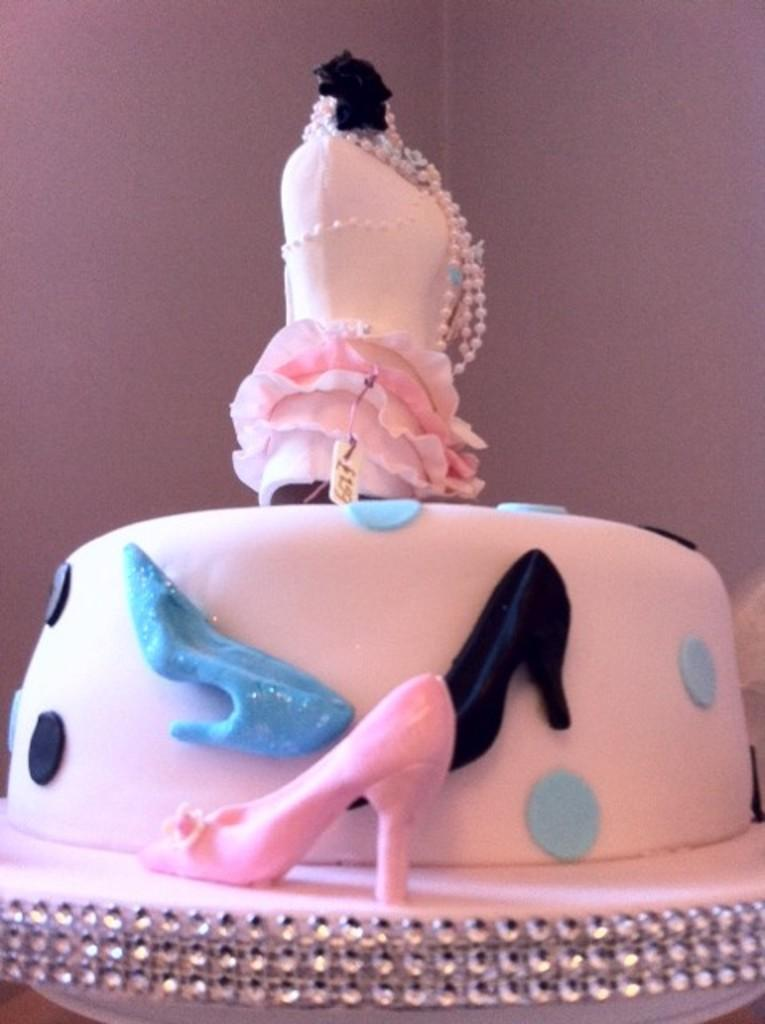What is the main subject in the center of the image? There is a cake in the center of the image. What can be seen in the background of the image? There is a wall in the background of the image. What type of game is being played in the image? There is no game being played in the image; it features a cake and a wall in the background. How many kittens can be seen playing with the bait in the image? There are no kittens or bait present in the image. 